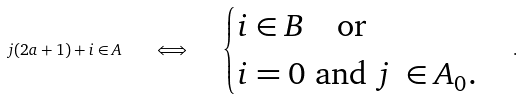Convert formula to latex. <formula><loc_0><loc_0><loc_500><loc_500>j ( 2 a + 1 ) + i \in A \quad \Longleftrightarrow \quad \begin{cases} i \in B \quad \text {or} \\ i = 0 \ \text {and} \ j \ \in A _ { 0 } . \end{cases} .</formula> 